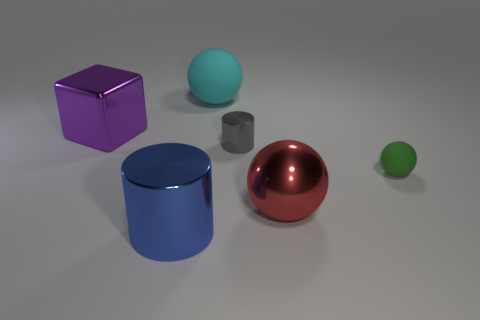Add 1 tiny purple rubber objects. How many objects exist? 7 Subtract all cylinders. How many objects are left? 4 Add 6 purple metal cubes. How many purple metal cubes are left? 7 Add 6 large purple blocks. How many large purple blocks exist? 7 Subtract 1 green balls. How many objects are left? 5 Subtract all green matte spheres. Subtract all big balls. How many objects are left? 3 